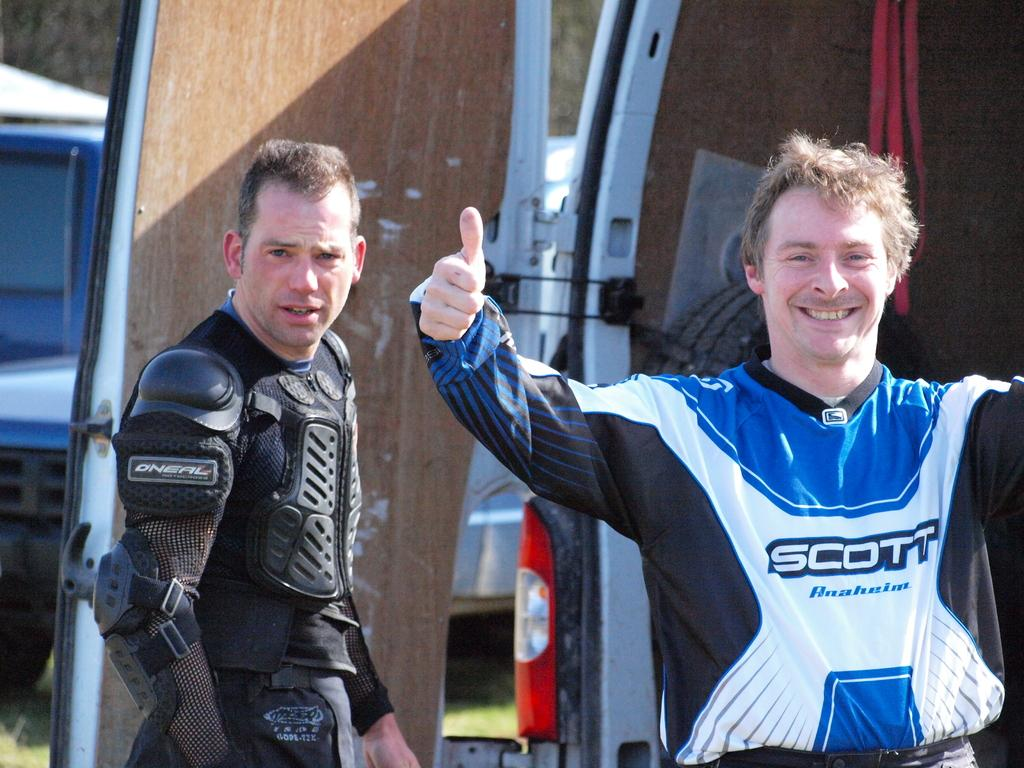<image>
Offer a succinct explanation of the picture presented. One competitor is sponsored by Scott and the other by O'Neal. 